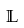Convert formula to latex. <formula><loc_0><loc_0><loc_500><loc_500>\mathbb { L }</formula> 